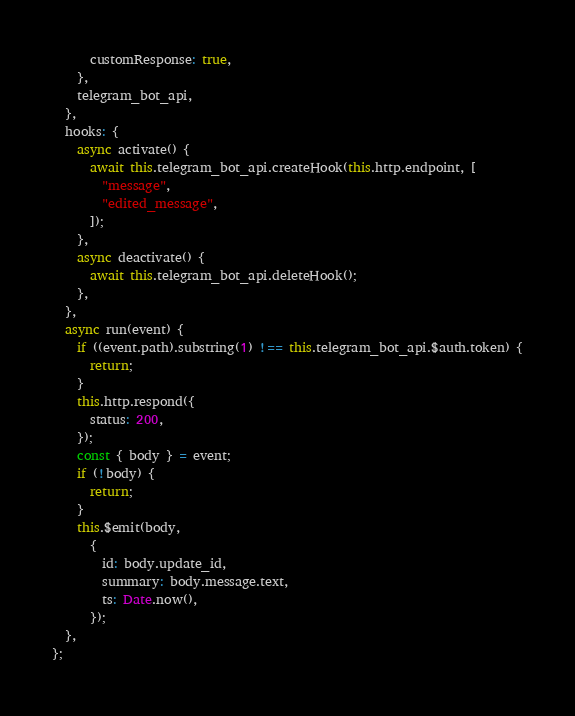Convert code to text. <code><loc_0><loc_0><loc_500><loc_500><_JavaScript_>      customResponse: true,
    },
    telegram_bot_api,
  },
  hooks: {
    async activate() {
      await this.telegram_bot_api.createHook(this.http.endpoint, [
        "message",
        "edited_message",
      ]);
    },
    async deactivate() {
      await this.telegram_bot_api.deleteHook();
    },
  },
  async run(event) {
    if ((event.path).substring(1) !== this.telegram_bot_api.$auth.token) {
      return;
    }
    this.http.respond({
      status: 200,
    });
    const { body } = event;
    if (!body) {
      return;
    }
    this.$emit(body,
      {
        id: body.update_id,
        summary: body.message.text,
        ts: Date.now(),
      });
  },
};
</code> 